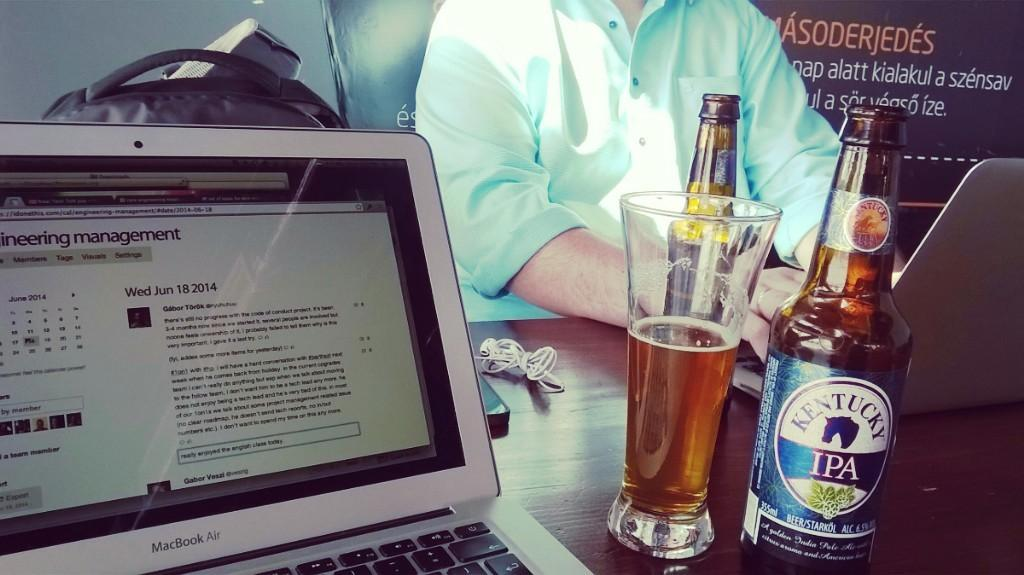<image>
Summarize the visual content of the image. A bottle of Kentucky IPA is next to a laptop. 